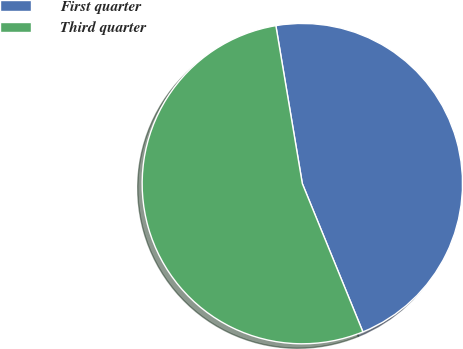<chart> <loc_0><loc_0><loc_500><loc_500><pie_chart><fcel>First quarter<fcel>Third quarter<nl><fcel>46.47%<fcel>53.53%<nl></chart> 